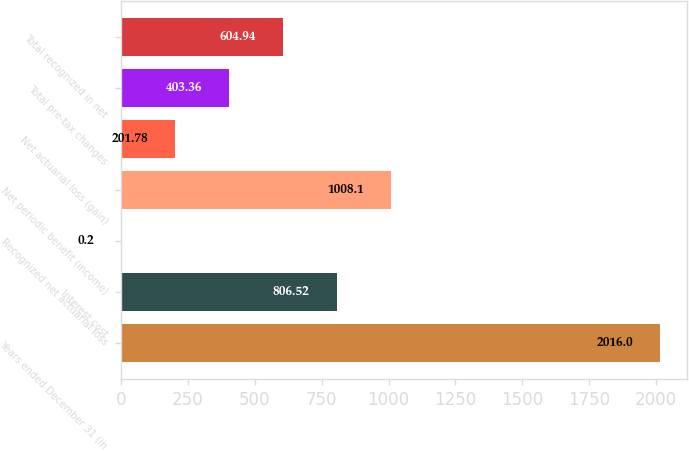<chart> <loc_0><loc_0><loc_500><loc_500><bar_chart><fcel>Years ended December 31 (in<fcel>Interest cost<fcel>Recognized net actuarial loss<fcel>Net periodic benefit (income)<fcel>Net actuarial loss (gain)<fcel>Total pre-tax changes<fcel>Total recognized in net<nl><fcel>2016<fcel>806.52<fcel>0.2<fcel>1008.1<fcel>201.78<fcel>403.36<fcel>604.94<nl></chart> 